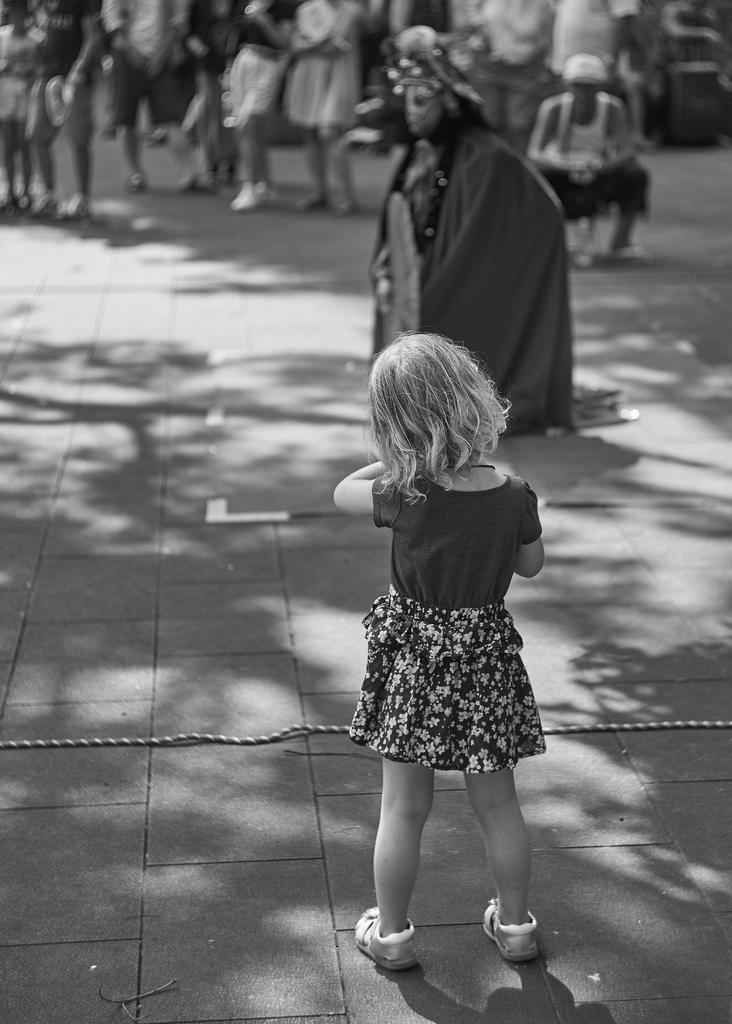In one or two sentences, can you explain what this image depicts? In this picture there is a girl standing in the foreground. At the back there are group of people standing and there is a person sitting and there is a person with costume. At the bottom there is a shadow of a tree and there is a wire. 